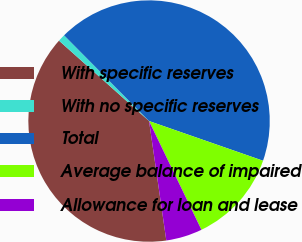<chart> <loc_0><loc_0><loc_500><loc_500><pie_chart><fcel>With specific reserves<fcel>With no specific reserves<fcel>Total<fcel>Average balance of impaired<fcel>Allowance for loan and lease<nl><fcel>38.88%<fcel>0.97%<fcel>42.76%<fcel>12.52%<fcel>4.86%<nl></chart> 